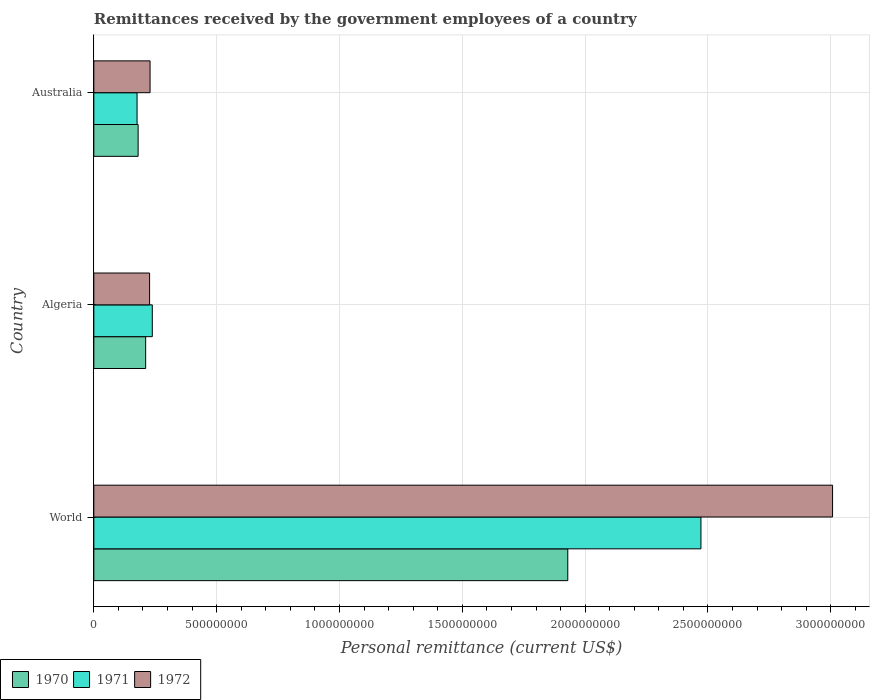Are the number of bars on each tick of the Y-axis equal?
Ensure brevity in your answer.  Yes. What is the label of the 2nd group of bars from the top?
Make the answer very short. Algeria. In how many cases, is the number of bars for a given country not equal to the number of legend labels?
Your answer should be very brief. 0. What is the remittances received by the government employees in 1970 in Algeria?
Keep it short and to the point. 2.11e+08. Across all countries, what is the maximum remittances received by the government employees in 1971?
Provide a succinct answer. 2.47e+09. Across all countries, what is the minimum remittances received by the government employees in 1971?
Offer a very short reply. 1.76e+08. In which country was the remittances received by the government employees in 1971 minimum?
Offer a terse response. Australia. What is the total remittances received by the government employees in 1970 in the graph?
Offer a terse response. 2.32e+09. What is the difference between the remittances received by the government employees in 1970 in Algeria and that in World?
Your response must be concise. -1.72e+09. What is the difference between the remittances received by the government employees in 1972 in World and the remittances received by the government employees in 1971 in Australia?
Your answer should be compact. 2.83e+09. What is the average remittances received by the government employees in 1971 per country?
Offer a terse response. 9.62e+08. What is the difference between the remittances received by the government employees in 1972 and remittances received by the government employees in 1971 in World?
Give a very brief answer. 5.36e+08. In how many countries, is the remittances received by the government employees in 1971 greater than 1900000000 US$?
Provide a short and direct response. 1. What is the ratio of the remittances received by the government employees in 1970 in Algeria to that in World?
Your answer should be very brief. 0.11. Is the remittances received by the government employees in 1972 in Algeria less than that in Australia?
Your answer should be very brief. Yes. Is the difference between the remittances received by the government employees in 1972 in Australia and World greater than the difference between the remittances received by the government employees in 1971 in Australia and World?
Offer a terse response. No. What is the difference between the highest and the second highest remittances received by the government employees in 1970?
Give a very brief answer. 1.72e+09. What is the difference between the highest and the lowest remittances received by the government employees in 1972?
Offer a terse response. 2.78e+09. In how many countries, is the remittances received by the government employees in 1972 greater than the average remittances received by the government employees in 1972 taken over all countries?
Offer a terse response. 1. What does the 3rd bar from the top in World represents?
Keep it short and to the point. 1970. What does the 3rd bar from the bottom in Australia represents?
Ensure brevity in your answer.  1972. How many bars are there?
Your response must be concise. 9. What is the difference between two consecutive major ticks on the X-axis?
Make the answer very short. 5.00e+08. Does the graph contain any zero values?
Give a very brief answer. No. Does the graph contain grids?
Provide a succinct answer. Yes. What is the title of the graph?
Offer a very short reply. Remittances received by the government employees of a country. What is the label or title of the X-axis?
Offer a terse response. Personal remittance (current US$). What is the label or title of the Y-axis?
Make the answer very short. Country. What is the Personal remittance (current US$) of 1970 in World?
Keep it short and to the point. 1.93e+09. What is the Personal remittance (current US$) of 1971 in World?
Offer a terse response. 2.47e+09. What is the Personal remittance (current US$) of 1972 in World?
Provide a short and direct response. 3.01e+09. What is the Personal remittance (current US$) of 1970 in Algeria?
Make the answer very short. 2.11e+08. What is the Personal remittance (current US$) of 1971 in Algeria?
Offer a very short reply. 2.38e+08. What is the Personal remittance (current US$) in 1972 in Algeria?
Offer a terse response. 2.27e+08. What is the Personal remittance (current US$) of 1970 in Australia?
Ensure brevity in your answer.  1.80e+08. What is the Personal remittance (current US$) of 1971 in Australia?
Provide a short and direct response. 1.76e+08. What is the Personal remittance (current US$) in 1972 in Australia?
Offer a terse response. 2.29e+08. Across all countries, what is the maximum Personal remittance (current US$) in 1970?
Keep it short and to the point. 1.93e+09. Across all countries, what is the maximum Personal remittance (current US$) in 1971?
Offer a very short reply. 2.47e+09. Across all countries, what is the maximum Personal remittance (current US$) of 1972?
Offer a very short reply. 3.01e+09. Across all countries, what is the minimum Personal remittance (current US$) of 1970?
Keep it short and to the point. 1.80e+08. Across all countries, what is the minimum Personal remittance (current US$) in 1971?
Provide a short and direct response. 1.76e+08. Across all countries, what is the minimum Personal remittance (current US$) in 1972?
Your response must be concise. 2.27e+08. What is the total Personal remittance (current US$) in 1970 in the graph?
Make the answer very short. 2.32e+09. What is the total Personal remittance (current US$) of 1971 in the graph?
Your response must be concise. 2.89e+09. What is the total Personal remittance (current US$) in 1972 in the graph?
Ensure brevity in your answer.  3.46e+09. What is the difference between the Personal remittance (current US$) in 1970 in World and that in Algeria?
Ensure brevity in your answer.  1.72e+09. What is the difference between the Personal remittance (current US$) in 1971 in World and that in Algeria?
Provide a succinct answer. 2.23e+09. What is the difference between the Personal remittance (current US$) in 1972 in World and that in Algeria?
Keep it short and to the point. 2.78e+09. What is the difference between the Personal remittance (current US$) in 1970 in World and that in Australia?
Provide a short and direct response. 1.75e+09. What is the difference between the Personal remittance (current US$) of 1971 in World and that in Australia?
Provide a short and direct response. 2.30e+09. What is the difference between the Personal remittance (current US$) of 1972 in World and that in Australia?
Provide a short and direct response. 2.78e+09. What is the difference between the Personal remittance (current US$) of 1970 in Algeria and that in Australia?
Offer a very short reply. 3.07e+07. What is the difference between the Personal remittance (current US$) in 1971 in Algeria and that in Australia?
Your answer should be compact. 6.20e+07. What is the difference between the Personal remittance (current US$) of 1972 in Algeria and that in Australia?
Your answer should be compact. -1.96e+06. What is the difference between the Personal remittance (current US$) in 1970 in World and the Personal remittance (current US$) in 1971 in Algeria?
Offer a very short reply. 1.69e+09. What is the difference between the Personal remittance (current US$) in 1970 in World and the Personal remittance (current US$) in 1972 in Algeria?
Provide a short and direct response. 1.70e+09. What is the difference between the Personal remittance (current US$) of 1971 in World and the Personal remittance (current US$) of 1972 in Algeria?
Give a very brief answer. 2.24e+09. What is the difference between the Personal remittance (current US$) in 1970 in World and the Personal remittance (current US$) in 1971 in Australia?
Make the answer very short. 1.75e+09. What is the difference between the Personal remittance (current US$) in 1970 in World and the Personal remittance (current US$) in 1972 in Australia?
Offer a very short reply. 1.70e+09. What is the difference between the Personal remittance (current US$) in 1971 in World and the Personal remittance (current US$) in 1972 in Australia?
Provide a short and direct response. 2.24e+09. What is the difference between the Personal remittance (current US$) in 1970 in Algeria and the Personal remittance (current US$) in 1971 in Australia?
Keep it short and to the point. 3.50e+07. What is the difference between the Personal remittance (current US$) in 1970 in Algeria and the Personal remittance (current US$) in 1972 in Australia?
Your answer should be very brief. -1.80e+07. What is the difference between the Personal remittance (current US$) in 1971 in Algeria and the Personal remittance (current US$) in 1972 in Australia?
Offer a very short reply. 9.04e+06. What is the average Personal remittance (current US$) of 1970 per country?
Ensure brevity in your answer.  7.74e+08. What is the average Personal remittance (current US$) in 1971 per country?
Ensure brevity in your answer.  9.62e+08. What is the average Personal remittance (current US$) in 1972 per country?
Your response must be concise. 1.15e+09. What is the difference between the Personal remittance (current US$) in 1970 and Personal remittance (current US$) in 1971 in World?
Give a very brief answer. -5.42e+08. What is the difference between the Personal remittance (current US$) of 1970 and Personal remittance (current US$) of 1972 in World?
Offer a very short reply. -1.08e+09. What is the difference between the Personal remittance (current US$) in 1971 and Personal remittance (current US$) in 1972 in World?
Offer a very short reply. -5.36e+08. What is the difference between the Personal remittance (current US$) of 1970 and Personal remittance (current US$) of 1971 in Algeria?
Your response must be concise. -2.70e+07. What is the difference between the Personal remittance (current US$) of 1970 and Personal remittance (current US$) of 1972 in Algeria?
Make the answer very short. -1.60e+07. What is the difference between the Personal remittance (current US$) in 1971 and Personal remittance (current US$) in 1972 in Algeria?
Your answer should be very brief. 1.10e+07. What is the difference between the Personal remittance (current US$) in 1970 and Personal remittance (current US$) in 1971 in Australia?
Ensure brevity in your answer.  4.27e+06. What is the difference between the Personal remittance (current US$) in 1970 and Personal remittance (current US$) in 1972 in Australia?
Your answer should be very brief. -4.86e+07. What is the difference between the Personal remittance (current US$) of 1971 and Personal remittance (current US$) of 1972 in Australia?
Your answer should be very brief. -5.29e+07. What is the ratio of the Personal remittance (current US$) in 1970 in World to that in Algeria?
Your answer should be compact. 9.14. What is the ratio of the Personal remittance (current US$) in 1971 in World to that in Algeria?
Ensure brevity in your answer.  10.38. What is the ratio of the Personal remittance (current US$) of 1972 in World to that in Algeria?
Keep it short and to the point. 13.25. What is the ratio of the Personal remittance (current US$) in 1970 in World to that in Australia?
Keep it short and to the point. 10.7. What is the ratio of the Personal remittance (current US$) of 1971 in World to that in Australia?
Your answer should be very brief. 14.04. What is the ratio of the Personal remittance (current US$) of 1972 in World to that in Australia?
Provide a succinct answer. 13.13. What is the ratio of the Personal remittance (current US$) of 1970 in Algeria to that in Australia?
Provide a succinct answer. 1.17. What is the ratio of the Personal remittance (current US$) of 1971 in Algeria to that in Australia?
Your response must be concise. 1.35. What is the difference between the highest and the second highest Personal remittance (current US$) in 1970?
Make the answer very short. 1.72e+09. What is the difference between the highest and the second highest Personal remittance (current US$) in 1971?
Offer a very short reply. 2.23e+09. What is the difference between the highest and the second highest Personal remittance (current US$) of 1972?
Keep it short and to the point. 2.78e+09. What is the difference between the highest and the lowest Personal remittance (current US$) in 1970?
Offer a very short reply. 1.75e+09. What is the difference between the highest and the lowest Personal remittance (current US$) in 1971?
Provide a short and direct response. 2.30e+09. What is the difference between the highest and the lowest Personal remittance (current US$) of 1972?
Make the answer very short. 2.78e+09. 